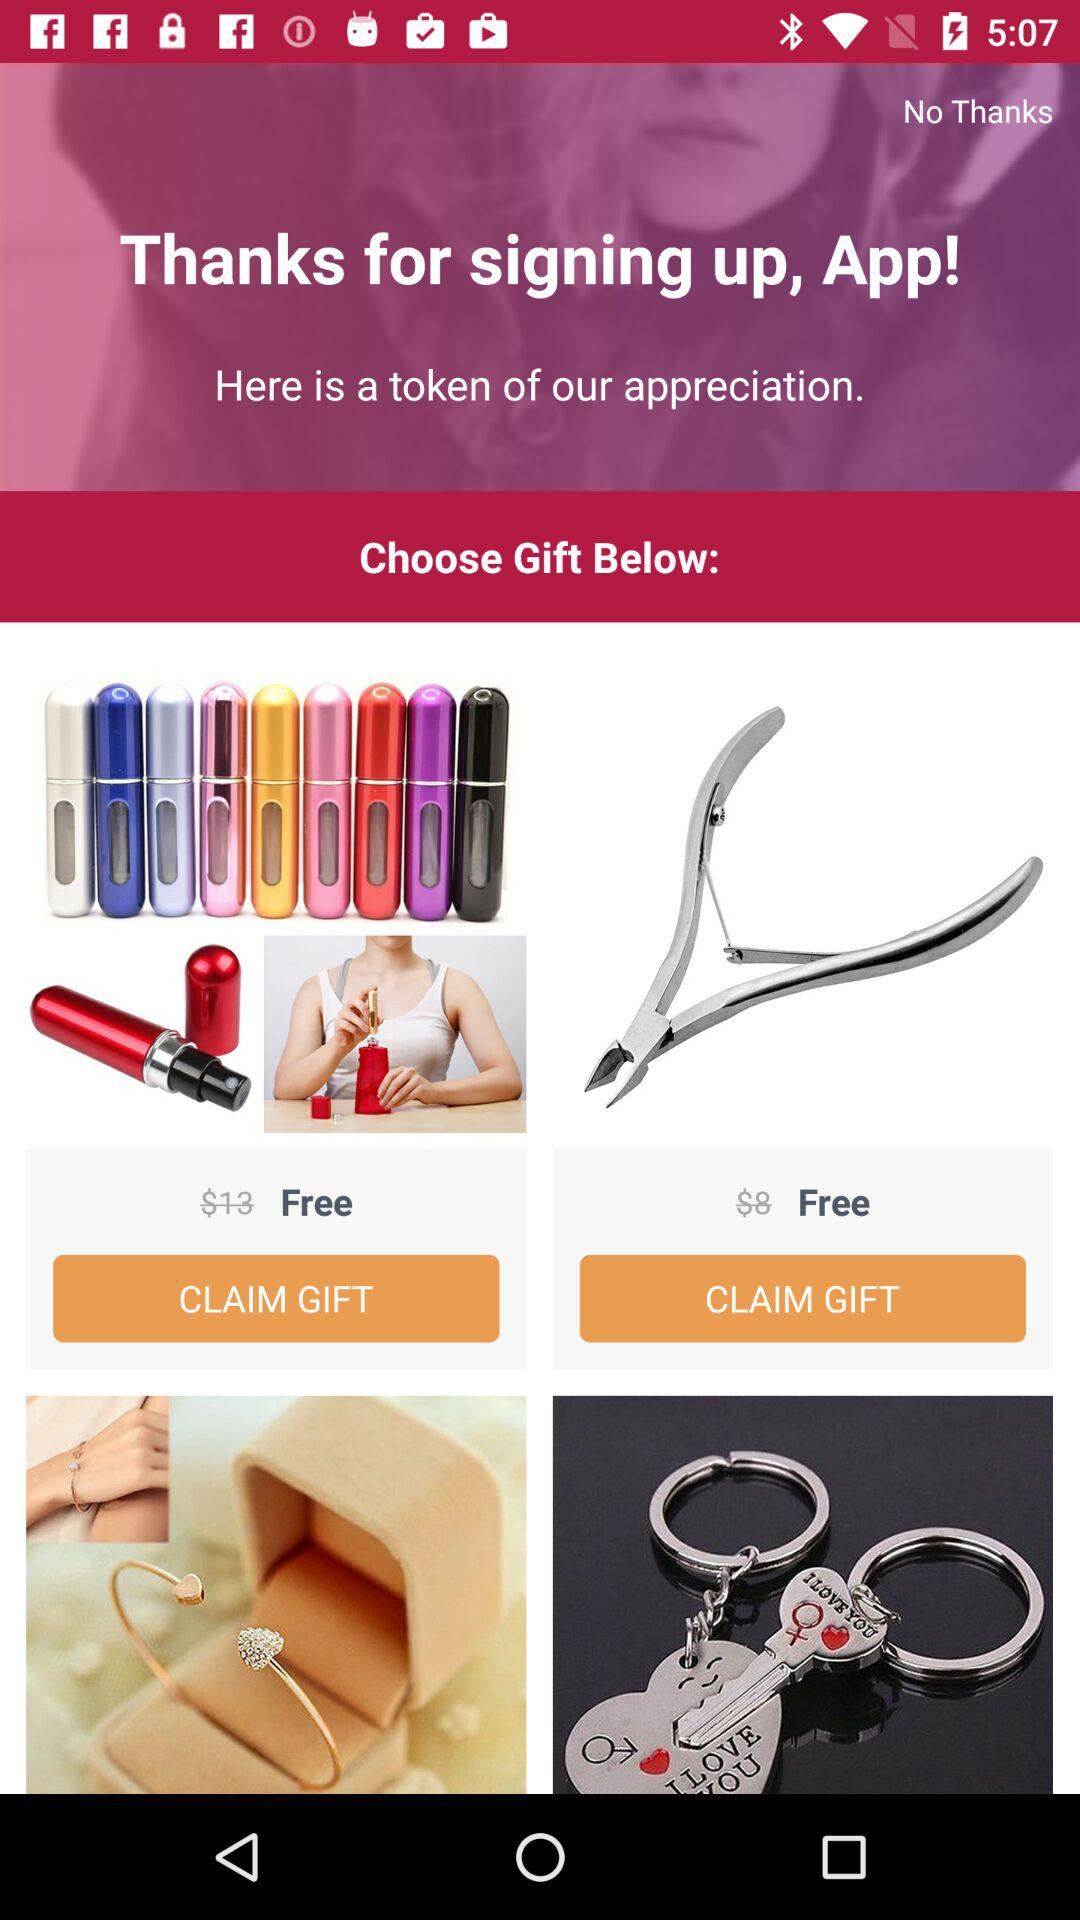How many gifts are there?
Answer the question using a single word or phrase. 4 